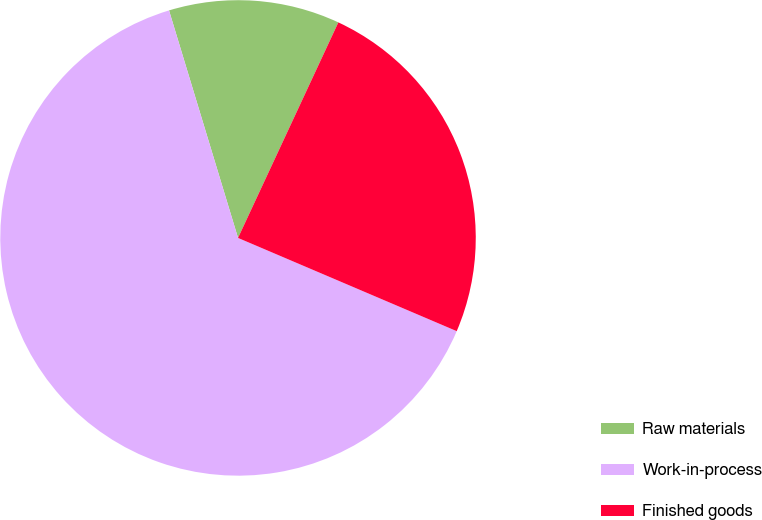Convert chart. <chart><loc_0><loc_0><loc_500><loc_500><pie_chart><fcel>Raw materials<fcel>Work-in-process<fcel>Finished goods<nl><fcel>11.62%<fcel>63.9%<fcel>24.48%<nl></chart> 